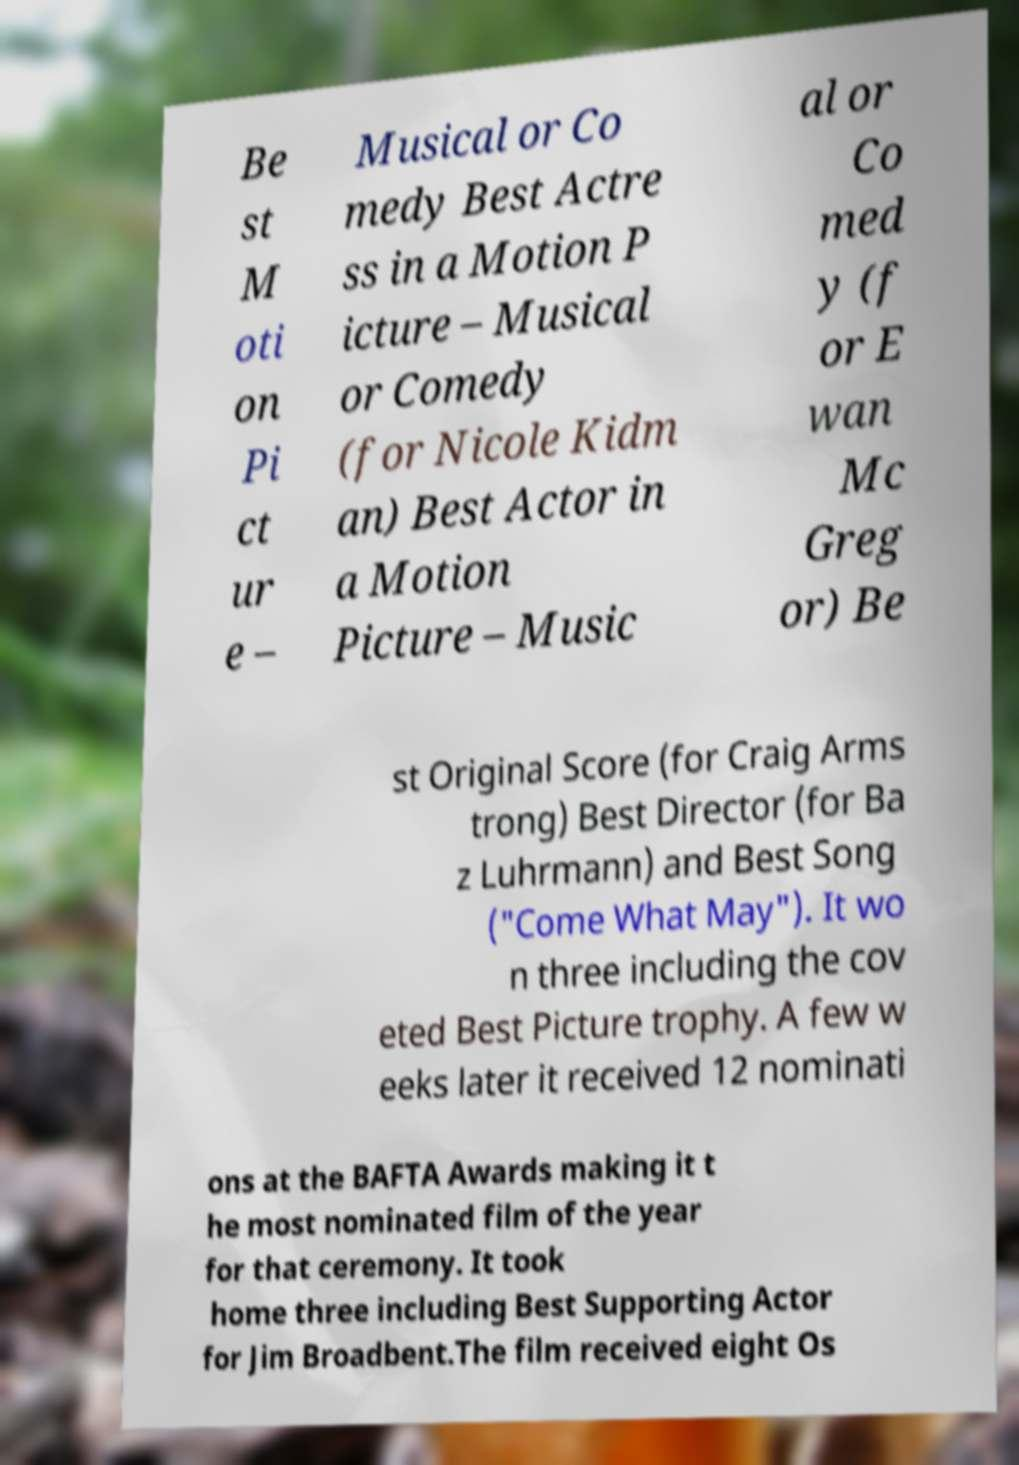There's text embedded in this image that I need extracted. Can you transcribe it verbatim? Be st M oti on Pi ct ur e – Musical or Co medy Best Actre ss in a Motion P icture – Musical or Comedy (for Nicole Kidm an) Best Actor in a Motion Picture – Music al or Co med y (f or E wan Mc Greg or) Be st Original Score (for Craig Arms trong) Best Director (for Ba z Luhrmann) and Best Song ("Come What May"). It wo n three including the cov eted Best Picture trophy. A few w eeks later it received 12 nominati ons at the BAFTA Awards making it t he most nominated film of the year for that ceremony. It took home three including Best Supporting Actor for Jim Broadbent.The film received eight Os 